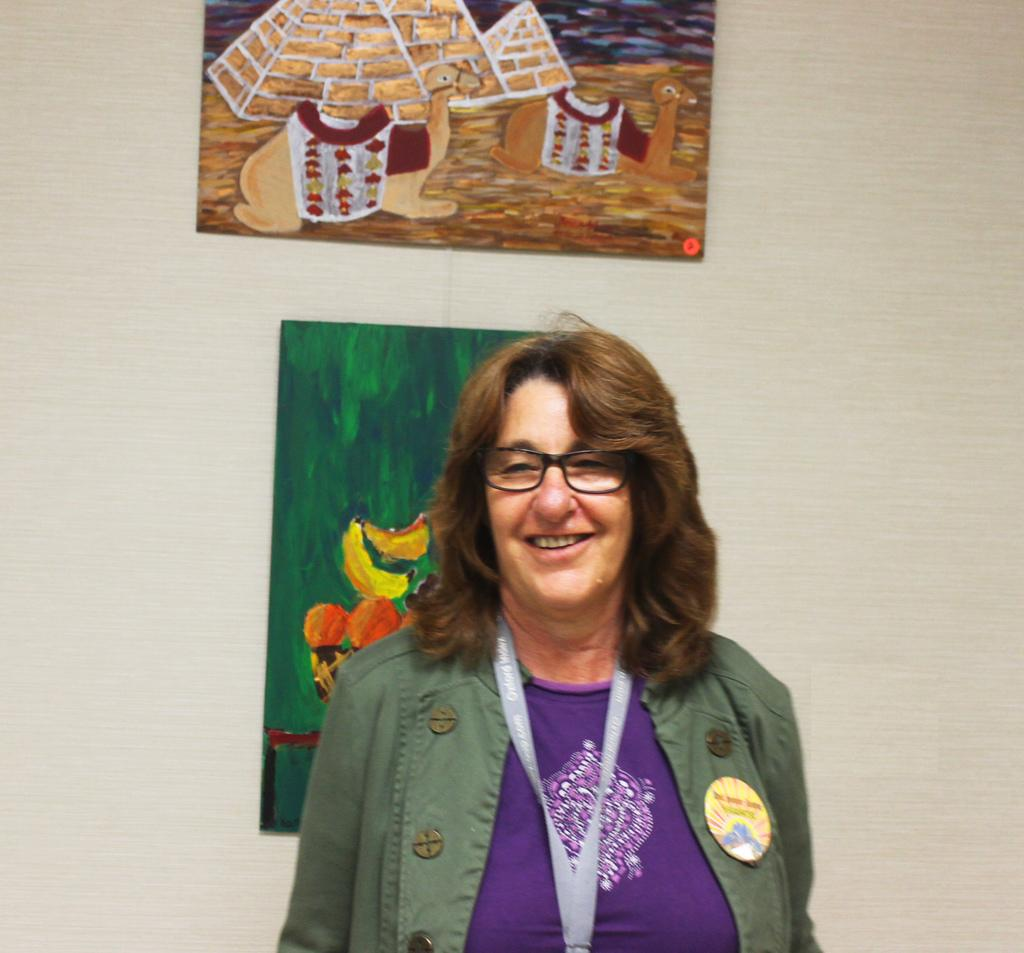Who is present in the image? There is a woman in the image. What is the woman doing in the image? The woman is standing in front of a wall and smiling. What is the woman wearing in the image? The woman is wearing a badge and an ID card. What can be seen on the wall behind the woman? There are two paintings attached to the wall behind the woman. What type of metal is used to create the brick wall in the image? There is no brick wall present in the image, and therefore no metal can be associated with it. 